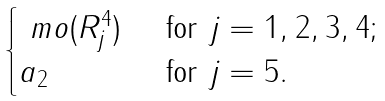Convert formula to latex. <formula><loc_0><loc_0><loc_500><loc_500>\begin{cases} \ m o ( R ^ { 4 } _ { j } ) & \text {\ for\ } j = 1 , 2 , 3 , 4 ; \\ a _ { 2 } & \text {\ for\ } j = 5 . \end{cases}</formula> 